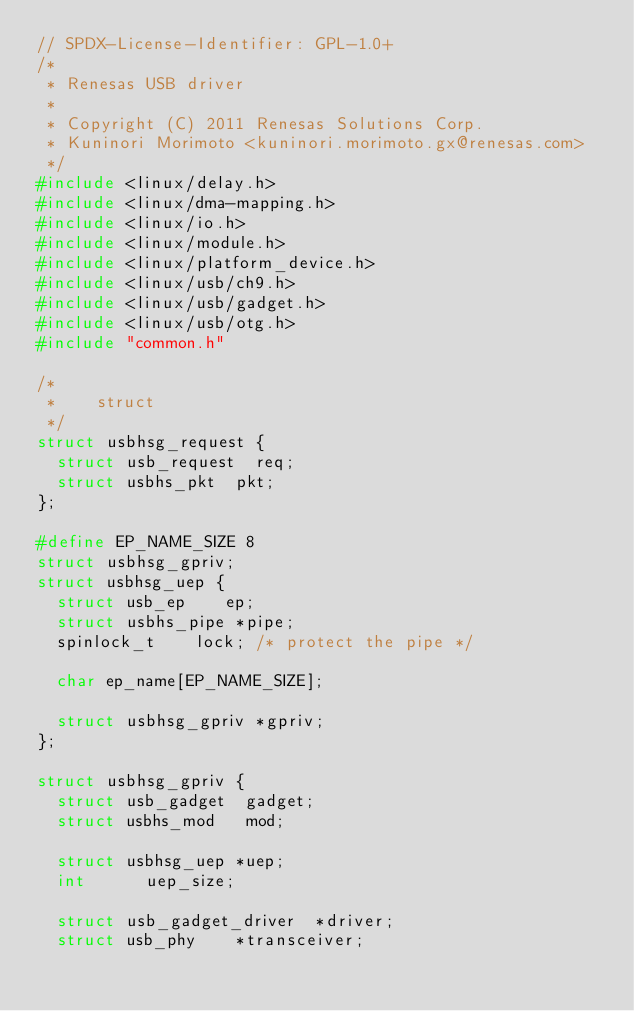<code> <loc_0><loc_0><loc_500><loc_500><_C_>// SPDX-License-Identifier: GPL-1.0+
/*
 * Renesas USB driver
 *
 * Copyright (C) 2011 Renesas Solutions Corp.
 * Kuninori Morimoto <kuninori.morimoto.gx@renesas.com>
 */
#include <linux/delay.h>
#include <linux/dma-mapping.h>
#include <linux/io.h>
#include <linux/module.h>
#include <linux/platform_device.h>
#include <linux/usb/ch9.h>
#include <linux/usb/gadget.h>
#include <linux/usb/otg.h>
#include "common.h"

/*
 *		struct
 */
struct usbhsg_request {
	struct usb_request	req;
	struct usbhs_pkt	pkt;
};

#define EP_NAME_SIZE 8
struct usbhsg_gpriv;
struct usbhsg_uep {
	struct usb_ep		 ep;
	struct usbhs_pipe	*pipe;
	spinlock_t		lock;	/* protect the pipe */

	char ep_name[EP_NAME_SIZE];

	struct usbhsg_gpriv *gpriv;
};

struct usbhsg_gpriv {
	struct usb_gadget	 gadget;
	struct usbhs_mod	 mod;

	struct usbhsg_uep	*uep;
	int			 uep_size;

	struct usb_gadget_driver	*driver;
	struct usb_phy		*transceiver;</code> 